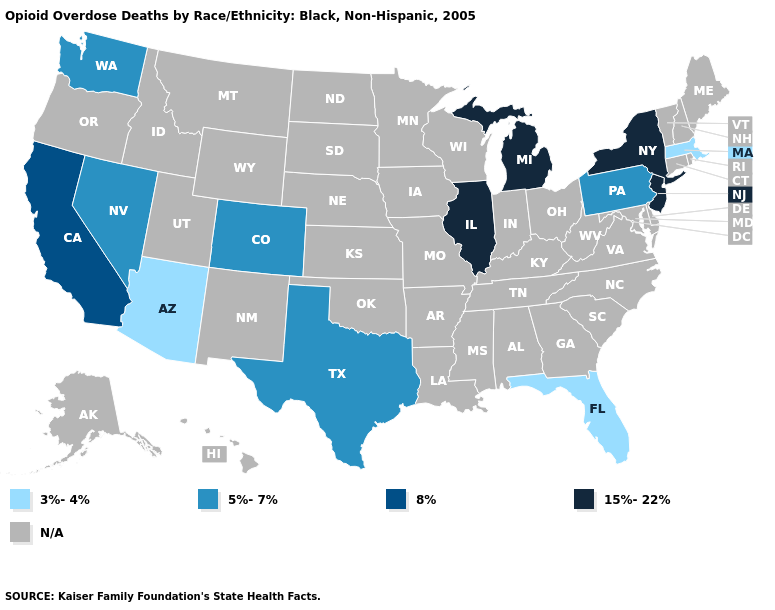What is the value of Washington?
Give a very brief answer. 5%-7%. How many symbols are there in the legend?
Keep it brief. 5. Does New Jersey have the lowest value in the Northeast?
Keep it brief. No. Which states have the lowest value in the USA?
Write a very short answer. Arizona, Florida, Massachusetts. What is the value of Connecticut?
Concise answer only. N/A. Name the states that have a value in the range N/A?
Short answer required. Alabama, Alaska, Arkansas, Connecticut, Delaware, Georgia, Hawaii, Idaho, Indiana, Iowa, Kansas, Kentucky, Louisiana, Maine, Maryland, Minnesota, Mississippi, Missouri, Montana, Nebraska, New Hampshire, New Mexico, North Carolina, North Dakota, Ohio, Oklahoma, Oregon, Rhode Island, South Carolina, South Dakota, Tennessee, Utah, Vermont, Virginia, West Virginia, Wisconsin, Wyoming. What is the highest value in the MidWest ?
Be succinct. 15%-22%. What is the value of Kansas?
Answer briefly. N/A. What is the lowest value in states that border Wyoming?
Quick response, please. 5%-7%. Among the states that border Indiana , which have the highest value?
Concise answer only. Illinois, Michigan. Name the states that have a value in the range 3%-4%?
Be succinct. Arizona, Florida, Massachusetts. What is the lowest value in the Northeast?
Keep it brief. 3%-4%. What is the value of Rhode Island?
Be succinct. N/A. 